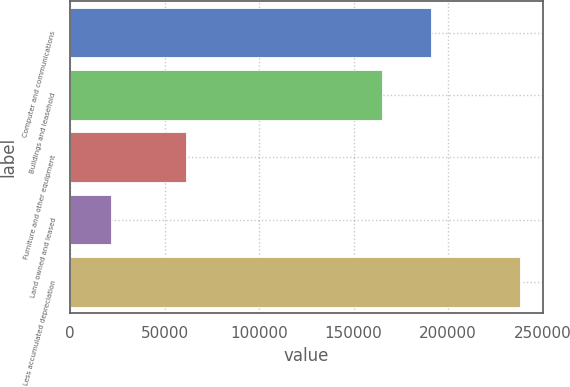Convert chart to OTSL. <chart><loc_0><loc_0><loc_500><loc_500><bar_chart><fcel>Computer and communications<fcel>Buildings and leasehold<fcel>Furniture and other equipment<fcel>Land owned and leased<fcel>Less accumulated depreciation<nl><fcel>191118<fcel>165127<fcel>61479<fcel>21503<fcel>238133<nl></chart> 